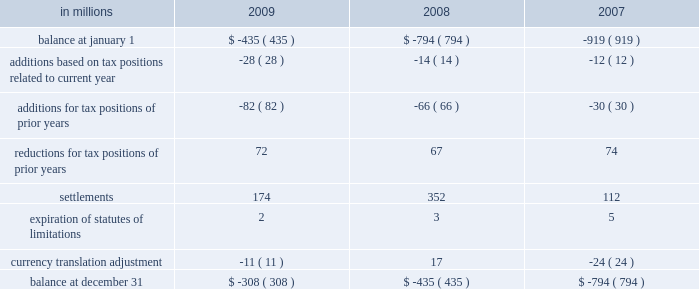Deferred tax assets and liabilities are recorded in the accompanying consolidated balance sheet under the captions deferred income tax assets , deferred charges and other assets , other accrued liabilities and deferred income taxes .
The decrease in 2009 in deferred tax assets principally relates to the tax impact of changes in recorded qualified pension liabilities , minimum tax credit utilization and an increase in the valuation allowance .
The decrease in deferred income tax liabilities principally relates to less tax depreciation taken on the company 2019s assets purchased in 2009 .
The valuation allowance for deferred tax assets as of december 31 , 2008 was $ 72 million .
The net change in the total valuation allowance for the year ended december 31 , 2009 , was an increase of $ 274 million .
The increase of $ 274 million consists primarily of : ( 1 ) $ 211 million related to the company 2019s french operations , including a valuation allowance of $ 55 million against net deferred tax assets from current year operations and $ 156 million recorded in the second quarter of 2009 for the establishment of a valuation allowance against previously recorded deferred tax assets , ( 2 ) $ 10 million for net deferred tax assets arising from the company 2019s united king- dom current year operations , and ( 3 ) $ 47 million related to a reduction of previously recorded u.s .
State deferred tax assets , including $ 15 million recorded in the fourth quarter of 2009 for louisiana recycling credits .
The effect on the company 2019s effec- tive tax rate of the aforementioned $ 211 million and $ 10 million is included in the line item 201ctax rate and permanent differences on non-u.s .
Earnings . 201d international paper adopted the provisions of new guidance under asc 740 , 201cincome taxes , 201d on jan- uary 1 , 2007 related to uncertain tax positions .
As a result of the implementation of this new guidance , the company recorded a charge to the beginning balance of retained earnings of $ 94 million , which was accounted for as a reduction to the january 1 , 2007 balance of retained earnings .
A reconciliation of the beginning and ending amount of unrecognized tax benefits for the year ending december 31 , 2009 and 2008 is as follows : in millions 2009 2008 2007 .
Included in the balance at december 31 , 2009 and 2008 are $ 56 million and $ 9 million , respectively , for tax positions for which the ultimate benefits are highly certain , but for which there is uncertainty about the timing of such benefits .
However , except for the possible effect of any penalties , any dis- allowance that would change the timing of these benefits would not affect the annual effective tax rate , but would accelerate the payment of cash to the taxing authority to an earlier period .
The company accrues interest on unrecognized tax benefits as a component of interest expense .
Penal- ties , if incurred , are recognized as a component of income tax expense .
The company had approx- imately $ 95 million and $ 74 million accrued for the payment of estimated interest and penalties asso- ciated with unrecognized tax benefits at december 31 , 2009 and 2008 , respectively .
The major jurisdictions where the company files income tax returns are the united states , brazil , france , poland and russia .
Generally , tax years 2002 through 2009 remain open and subject to examina- tion by the relevant tax authorities .
The company is typically engaged in various tax examinations at any given time , both in the united states and overseas .
Currently , the company is engaged in discussions with the u.s .
Internal revenue service regarding the examination of tax years 2006 and 2007 .
As a result of these discussions , other pending tax audit settle- ments , and the expiration of statutes of limitation , the company currently estimates that the amount of unrecognized tax benefits could be reduced by up to $ 125 million during the next twelve months .
During 2009 , unrecognized tax benefits decreased by $ 127 million .
While the company believes that it is adequately accrued for possible audit adjustments , the final resolution of these examinations cannot be determined at this time and could result in final settlements that differ from current estimates .
The company 2019s 2009 income tax provision of $ 469 million included $ 279 million related to special items and other charges , consisting of a $ 534 million tax benefit related to restructuring and other charges , a $ 650 million tax expense for the alternative fuel mixture credit , and $ 163 million of tax-related adjustments including a $ 156 million tax expense to establish a valuation allowance for net operating loss carryforwards in france , a $ 26 million tax benefit for the effective settlement of federal tax audits , a $ 15 million tax expense to establish a valuation allow- ance for louisiana recycling credits , and $ 18 million of other income tax adjustments .
Excluding the impact of special items , the tax provision was .
What was the change in unrecognized tax benefits between 2007 and 2008? 
Computations: (-435 - -794)
Answer: 359.0. 